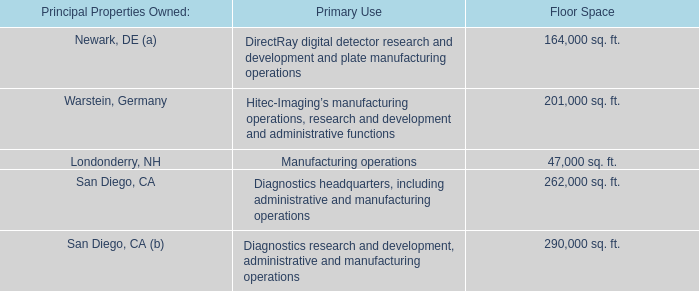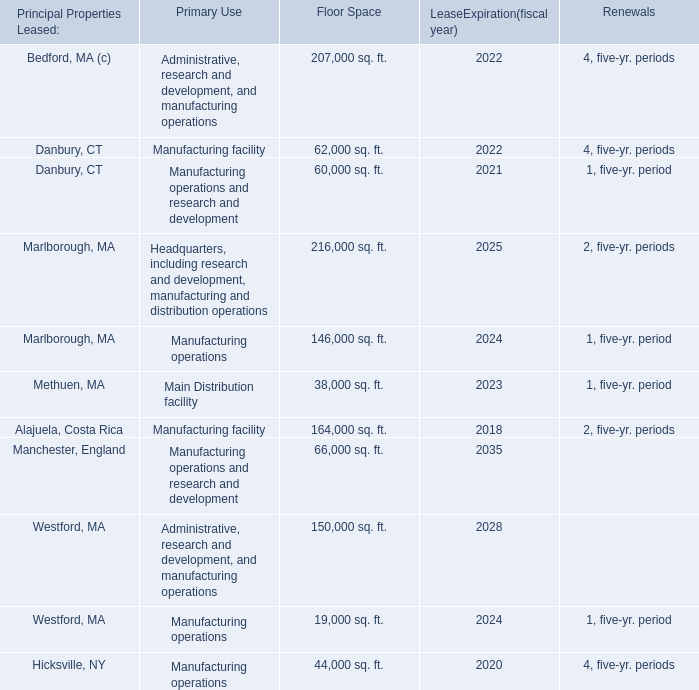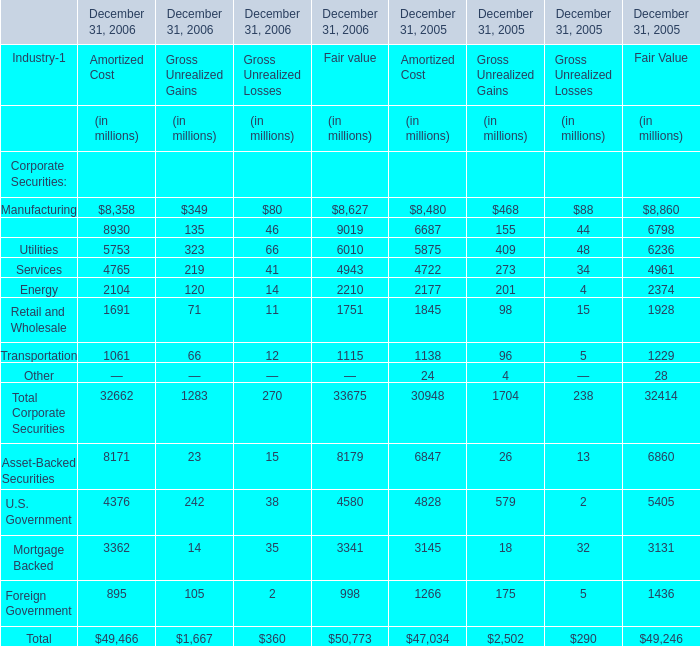what was the change in interest paid between 2011 and 2012 in millions? 
Computations: (67.8 - 55.0)
Answer: 12.8. 